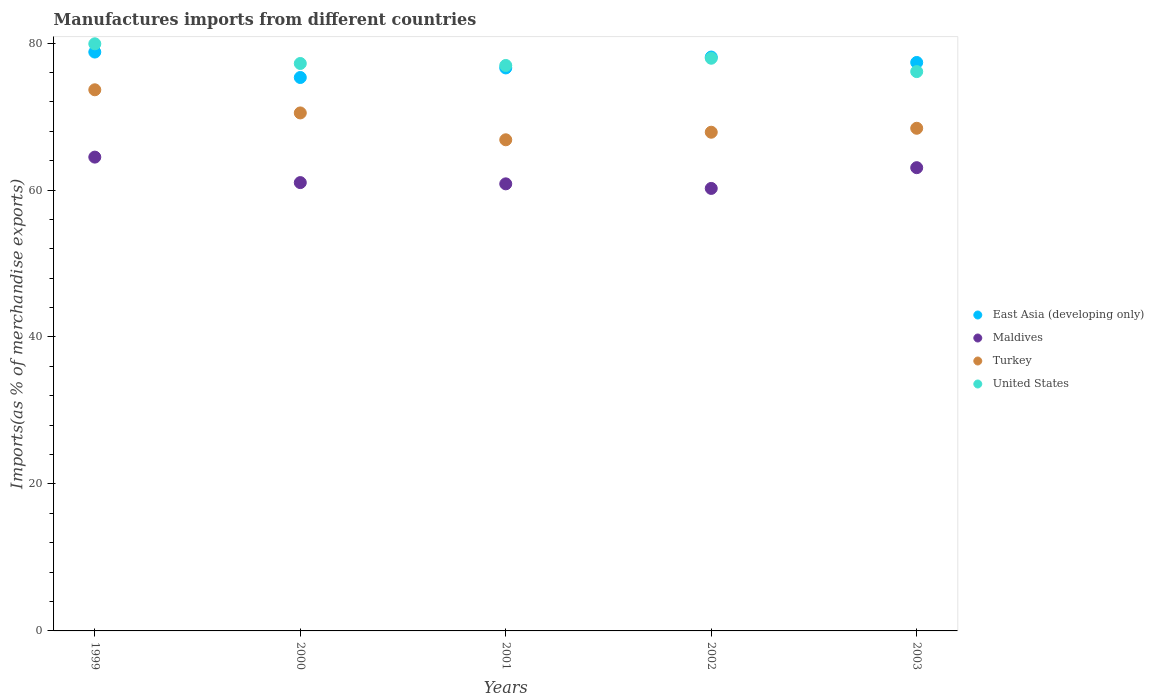How many different coloured dotlines are there?
Your answer should be compact. 4. What is the percentage of imports to different countries in Maldives in 2000?
Your answer should be very brief. 61.01. Across all years, what is the maximum percentage of imports to different countries in East Asia (developing only)?
Provide a succinct answer. 78.77. Across all years, what is the minimum percentage of imports to different countries in Maldives?
Provide a succinct answer. 60.22. In which year was the percentage of imports to different countries in East Asia (developing only) minimum?
Provide a short and direct response. 2000. What is the total percentage of imports to different countries in Turkey in the graph?
Ensure brevity in your answer.  347.23. What is the difference between the percentage of imports to different countries in East Asia (developing only) in 2000 and that in 2001?
Provide a short and direct response. -1.3. What is the difference between the percentage of imports to different countries in Turkey in 2002 and the percentage of imports to different countries in Maldives in 2000?
Ensure brevity in your answer.  6.86. What is the average percentage of imports to different countries in Turkey per year?
Your answer should be compact. 69.45. In the year 2003, what is the difference between the percentage of imports to different countries in United States and percentage of imports to different countries in Turkey?
Your answer should be very brief. 7.71. In how many years, is the percentage of imports to different countries in East Asia (developing only) greater than 56 %?
Provide a succinct answer. 5. What is the ratio of the percentage of imports to different countries in Turkey in 2000 to that in 2002?
Give a very brief answer. 1.04. Is the difference between the percentage of imports to different countries in United States in 1999 and 2003 greater than the difference between the percentage of imports to different countries in Turkey in 1999 and 2003?
Offer a very short reply. No. What is the difference between the highest and the second highest percentage of imports to different countries in Maldives?
Offer a terse response. 1.44. What is the difference between the highest and the lowest percentage of imports to different countries in East Asia (developing only)?
Provide a short and direct response. 3.46. In how many years, is the percentage of imports to different countries in Turkey greater than the average percentage of imports to different countries in Turkey taken over all years?
Provide a succinct answer. 2. Is it the case that in every year, the sum of the percentage of imports to different countries in Maldives and percentage of imports to different countries in Turkey  is greater than the sum of percentage of imports to different countries in East Asia (developing only) and percentage of imports to different countries in United States?
Make the answer very short. No. Is it the case that in every year, the sum of the percentage of imports to different countries in Maldives and percentage of imports to different countries in United States  is greater than the percentage of imports to different countries in Turkey?
Keep it short and to the point. Yes. Does the percentage of imports to different countries in Turkey monotonically increase over the years?
Make the answer very short. No. Is the percentage of imports to different countries in Turkey strictly greater than the percentage of imports to different countries in Maldives over the years?
Your response must be concise. Yes. Is the percentage of imports to different countries in United States strictly less than the percentage of imports to different countries in Turkey over the years?
Make the answer very short. No. What is the difference between two consecutive major ticks on the Y-axis?
Provide a short and direct response. 20. Where does the legend appear in the graph?
Give a very brief answer. Center right. What is the title of the graph?
Your response must be concise. Manufactures imports from different countries. Does "Cyprus" appear as one of the legend labels in the graph?
Provide a short and direct response. No. What is the label or title of the X-axis?
Ensure brevity in your answer.  Years. What is the label or title of the Y-axis?
Keep it short and to the point. Imports(as % of merchandise exports). What is the Imports(as % of merchandise exports) in East Asia (developing only) in 1999?
Give a very brief answer. 78.77. What is the Imports(as % of merchandise exports) in Maldives in 1999?
Your response must be concise. 64.48. What is the Imports(as % of merchandise exports) in Turkey in 1999?
Provide a short and direct response. 73.64. What is the Imports(as % of merchandise exports) in United States in 1999?
Your answer should be compact. 79.9. What is the Imports(as % of merchandise exports) of East Asia (developing only) in 2000?
Give a very brief answer. 75.31. What is the Imports(as % of merchandise exports) of Maldives in 2000?
Make the answer very short. 61.01. What is the Imports(as % of merchandise exports) of Turkey in 2000?
Give a very brief answer. 70.49. What is the Imports(as % of merchandise exports) of United States in 2000?
Your answer should be compact. 77.22. What is the Imports(as % of merchandise exports) in East Asia (developing only) in 2001?
Ensure brevity in your answer.  76.61. What is the Imports(as % of merchandise exports) in Maldives in 2001?
Your response must be concise. 60.84. What is the Imports(as % of merchandise exports) of Turkey in 2001?
Keep it short and to the point. 66.84. What is the Imports(as % of merchandise exports) in United States in 2001?
Give a very brief answer. 76.95. What is the Imports(as % of merchandise exports) of East Asia (developing only) in 2002?
Offer a terse response. 78.09. What is the Imports(as % of merchandise exports) in Maldives in 2002?
Your response must be concise. 60.22. What is the Imports(as % of merchandise exports) in Turkey in 2002?
Ensure brevity in your answer.  67.86. What is the Imports(as % of merchandise exports) of United States in 2002?
Keep it short and to the point. 77.93. What is the Imports(as % of merchandise exports) in East Asia (developing only) in 2003?
Offer a very short reply. 77.36. What is the Imports(as % of merchandise exports) in Maldives in 2003?
Your response must be concise. 63.04. What is the Imports(as % of merchandise exports) of Turkey in 2003?
Provide a short and direct response. 68.4. What is the Imports(as % of merchandise exports) of United States in 2003?
Ensure brevity in your answer.  76.11. Across all years, what is the maximum Imports(as % of merchandise exports) of East Asia (developing only)?
Make the answer very short. 78.77. Across all years, what is the maximum Imports(as % of merchandise exports) of Maldives?
Your response must be concise. 64.48. Across all years, what is the maximum Imports(as % of merchandise exports) in Turkey?
Give a very brief answer. 73.64. Across all years, what is the maximum Imports(as % of merchandise exports) of United States?
Give a very brief answer. 79.9. Across all years, what is the minimum Imports(as % of merchandise exports) in East Asia (developing only)?
Provide a succinct answer. 75.31. Across all years, what is the minimum Imports(as % of merchandise exports) in Maldives?
Give a very brief answer. 60.22. Across all years, what is the minimum Imports(as % of merchandise exports) in Turkey?
Ensure brevity in your answer.  66.84. Across all years, what is the minimum Imports(as % of merchandise exports) of United States?
Offer a terse response. 76.11. What is the total Imports(as % of merchandise exports) in East Asia (developing only) in the graph?
Offer a very short reply. 386.15. What is the total Imports(as % of merchandise exports) in Maldives in the graph?
Provide a succinct answer. 309.58. What is the total Imports(as % of merchandise exports) in Turkey in the graph?
Offer a terse response. 347.23. What is the total Imports(as % of merchandise exports) in United States in the graph?
Provide a short and direct response. 388.11. What is the difference between the Imports(as % of merchandise exports) in East Asia (developing only) in 1999 and that in 2000?
Ensure brevity in your answer.  3.46. What is the difference between the Imports(as % of merchandise exports) of Maldives in 1999 and that in 2000?
Provide a succinct answer. 3.47. What is the difference between the Imports(as % of merchandise exports) in Turkey in 1999 and that in 2000?
Your answer should be compact. 3.15. What is the difference between the Imports(as % of merchandise exports) of United States in 1999 and that in 2000?
Provide a short and direct response. 2.68. What is the difference between the Imports(as % of merchandise exports) in East Asia (developing only) in 1999 and that in 2001?
Offer a terse response. 2.16. What is the difference between the Imports(as % of merchandise exports) of Maldives in 1999 and that in 2001?
Your response must be concise. 3.64. What is the difference between the Imports(as % of merchandise exports) of Turkey in 1999 and that in 2001?
Keep it short and to the point. 6.8. What is the difference between the Imports(as % of merchandise exports) in United States in 1999 and that in 2001?
Your answer should be compact. 2.95. What is the difference between the Imports(as % of merchandise exports) of East Asia (developing only) in 1999 and that in 2002?
Your response must be concise. 0.68. What is the difference between the Imports(as % of merchandise exports) of Maldives in 1999 and that in 2002?
Your answer should be compact. 4.26. What is the difference between the Imports(as % of merchandise exports) in Turkey in 1999 and that in 2002?
Give a very brief answer. 5.77. What is the difference between the Imports(as % of merchandise exports) in United States in 1999 and that in 2002?
Ensure brevity in your answer.  1.96. What is the difference between the Imports(as % of merchandise exports) in East Asia (developing only) in 1999 and that in 2003?
Provide a short and direct response. 1.42. What is the difference between the Imports(as % of merchandise exports) in Maldives in 1999 and that in 2003?
Your answer should be very brief. 1.44. What is the difference between the Imports(as % of merchandise exports) of Turkey in 1999 and that in 2003?
Offer a terse response. 5.24. What is the difference between the Imports(as % of merchandise exports) of United States in 1999 and that in 2003?
Give a very brief answer. 3.78. What is the difference between the Imports(as % of merchandise exports) in East Asia (developing only) in 2000 and that in 2001?
Provide a short and direct response. -1.3. What is the difference between the Imports(as % of merchandise exports) of Maldives in 2000 and that in 2001?
Give a very brief answer. 0.17. What is the difference between the Imports(as % of merchandise exports) in Turkey in 2000 and that in 2001?
Provide a short and direct response. 3.65. What is the difference between the Imports(as % of merchandise exports) of United States in 2000 and that in 2001?
Make the answer very short. 0.27. What is the difference between the Imports(as % of merchandise exports) of East Asia (developing only) in 2000 and that in 2002?
Ensure brevity in your answer.  -2.78. What is the difference between the Imports(as % of merchandise exports) in Maldives in 2000 and that in 2002?
Provide a succinct answer. 0.79. What is the difference between the Imports(as % of merchandise exports) of Turkey in 2000 and that in 2002?
Make the answer very short. 2.63. What is the difference between the Imports(as % of merchandise exports) of United States in 2000 and that in 2002?
Make the answer very short. -0.71. What is the difference between the Imports(as % of merchandise exports) of East Asia (developing only) in 2000 and that in 2003?
Your answer should be very brief. -2.05. What is the difference between the Imports(as % of merchandise exports) of Maldives in 2000 and that in 2003?
Your response must be concise. -2.03. What is the difference between the Imports(as % of merchandise exports) in Turkey in 2000 and that in 2003?
Your answer should be compact. 2.09. What is the difference between the Imports(as % of merchandise exports) of United States in 2000 and that in 2003?
Your answer should be very brief. 1.1. What is the difference between the Imports(as % of merchandise exports) in East Asia (developing only) in 2001 and that in 2002?
Your answer should be very brief. -1.48. What is the difference between the Imports(as % of merchandise exports) of Maldives in 2001 and that in 2002?
Provide a succinct answer. 0.62. What is the difference between the Imports(as % of merchandise exports) of Turkey in 2001 and that in 2002?
Offer a very short reply. -1.03. What is the difference between the Imports(as % of merchandise exports) of United States in 2001 and that in 2002?
Offer a terse response. -0.98. What is the difference between the Imports(as % of merchandise exports) in East Asia (developing only) in 2001 and that in 2003?
Your response must be concise. -0.74. What is the difference between the Imports(as % of merchandise exports) of Maldives in 2001 and that in 2003?
Provide a short and direct response. -2.2. What is the difference between the Imports(as % of merchandise exports) of Turkey in 2001 and that in 2003?
Your answer should be very brief. -1.57. What is the difference between the Imports(as % of merchandise exports) of United States in 2001 and that in 2003?
Ensure brevity in your answer.  0.83. What is the difference between the Imports(as % of merchandise exports) of East Asia (developing only) in 2002 and that in 2003?
Your answer should be very brief. 0.74. What is the difference between the Imports(as % of merchandise exports) of Maldives in 2002 and that in 2003?
Offer a very short reply. -2.82. What is the difference between the Imports(as % of merchandise exports) in Turkey in 2002 and that in 2003?
Keep it short and to the point. -0.54. What is the difference between the Imports(as % of merchandise exports) in United States in 2002 and that in 2003?
Your answer should be compact. 1.82. What is the difference between the Imports(as % of merchandise exports) of East Asia (developing only) in 1999 and the Imports(as % of merchandise exports) of Maldives in 2000?
Keep it short and to the point. 17.76. What is the difference between the Imports(as % of merchandise exports) in East Asia (developing only) in 1999 and the Imports(as % of merchandise exports) in Turkey in 2000?
Make the answer very short. 8.28. What is the difference between the Imports(as % of merchandise exports) in East Asia (developing only) in 1999 and the Imports(as % of merchandise exports) in United States in 2000?
Your answer should be very brief. 1.55. What is the difference between the Imports(as % of merchandise exports) in Maldives in 1999 and the Imports(as % of merchandise exports) in Turkey in 2000?
Your answer should be very brief. -6.01. What is the difference between the Imports(as % of merchandise exports) of Maldives in 1999 and the Imports(as % of merchandise exports) of United States in 2000?
Offer a terse response. -12.74. What is the difference between the Imports(as % of merchandise exports) in Turkey in 1999 and the Imports(as % of merchandise exports) in United States in 2000?
Offer a very short reply. -3.58. What is the difference between the Imports(as % of merchandise exports) of East Asia (developing only) in 1999 and the Imports(as % of merchandise exports) of Maldives in 2001?
Your answer should be compact. 17.93. What is the difference between the Imports(as % of merchandise exports) in East Asia (developing only) in 1999 and the Imports(as % of merchandise exports) in Turkey in 2001?
Ensure brevity in your answer.  11.94. What is the difference between the Imports(as % of merchandise exports) in East Asia (developing only) in 1999 and the Imports(as % of merchandise exports) in United States in 2001?
Give a very brief answer. 1.82. What is the difference between the Imports(as % of merchandise exports) of Maldives in 1999 and the Imports(as % of merchandise exports) of Turkey in 2001?
Offer a terse response. -2.36. What is the difference between the Imports(as % of merchandise exports) of Maldives in 1999 and the Imports(as % of merchandise exports) of United States in 2001?
Provide a short and direct response. -12.47. What is the difference between the Imports(as % of merchandise exports) of Turkey in 1999 and the Imports(as % of merchandise exports) of United States in 2001?
Your response must be concise. -3.31. What is the difference between the Imports(as % of merchandise exports) in East Asia (developing only) in 1999 and the Imports(as % of merchandise exports) in Maldives in 2002?
Make the answer very short. 18.56. What is the difference between the Imports(as % of merchandise exports) in East Asia (developing only) in 1999 and the Imports(as % of merchandise exports) in Turkey in 2002?
Provide a succinct answer. 10.91. What is the difference between the Imports(as % of merchandise exports) of East Asia (developing only) in 1999 and the Imports(as % of merchandise exports) of United States in 2002?
Offer a terse response. 0.84. What is the difference between the Imports(as % of merchandise exports) of Maldives in 1999 and the Imports(as % of merchandise exports) of Turkey in 2002?
Keep it short and to the point. -3.39. What is the difference between the Imports(as % of merchandise exports) in Maldives in 1999 and the Imports(as % of merchandise exports) in United States in 2002?
Make the answer very short. -13.45. What is the difference between the Imports(as % of merchandise exports) in Turkey in 1999 and the Imports(as % of merchandise exports) in United States in 2002?
Your response must be concise. -4.29. What is the difference between the Imports(as % of merchandise exports) of East Asia (developing only) in 1999 and the Imports(as % of merchandise exports) of Maldives in 2003?
Provide a short and direct response. 15.73. What is the difference between the Imports(as % of merchandise exports) in East Asia (developing only) in 1999 and the Imports(as % of merchandise exports) in Turkey in 2003?
Provide a succinct answer. 10.37. What is the difference between the Imports(as % of merchandise exports) in East Asia (developing only) in 1999 and the Imports(as % of merchandise exports) in United States in 2003?
Offer a terse response. 2.66. What is the difference between the Imports(as % of merchandise exports) of Maldives in 1999 and the Imports(as % of merchandise exports) of Turkey in 2003?
Offer a very short reply. -3.93. What is the difference between the Imports(as % of merchandise exports) in Maldives in 1999 and the Imports(as % of merchandise exports) in United States in 2003?
Your answer should be very brief. -11.64. What is the difference between the Imports(as % of merchandise exports) in Turkey in 1999 and the Imports(as % of merchandise exports) in United States in 2003?
Give a very brief answer. -2.48. What is the difference between the Imports(as % of merchandise exports) of East Asia (developing only) in 2000 and the Imports(as % of merchandise exports) of Maldives in 2001?
Provide a succinct answer. 14.47. What is the difference between the Imports(as % of merchandise exports) in East Asia (developing only) in 2000 and the Imports(as % of merchandise exports) in Turkey in 2001?
Provide a succinct answer. 8.48. What is the difference between the Imports(as % of merchandise exports) of East Asia (developing only) in 2000 and the Imports(as % of merchandise exports) of United States in 2001?
Ensure brevity in your answer.  -1.64. What is the difference between the Imports(as % of merchandise exports) of Maldives in 2000 and the Imports(as % of merchandise exports) of Turkey in 2001?
Make the answer very short. -5.83. What is the difference between the Imports(as % of merchandise exports) of Maldives in 2000 and the Imports(as % of merchandise exports) of United States in 2001?
Your response must be concise. -15.94. What is the difference between the Imports(as % of merchandise exports) of Turkey in 2000 and the Imports(as % of merchandise exports) of United States in 2001?
Keep it short and to the point. -6.46. What is the difference between the Imports(as % of merchandise exports) in East Asia (developing only) in 2000 and the Imports(as % of merchandise exports) in Maldives in 2002?
Ensure brevity in your answer.  15.1. What is the difference between the Imports(as % of merchandise exports) in East Asia (developing only) in 2000 and the Imports(as % of merchandise exports) in Turkey in 2002?
Offer a terse response. 7.45. What is the difference between the Imports(as % of merchandise exports) in East Asia (developing only) in 2000 and the Imports(as % of merchandise exports) in United States in 2002?
Your response must be concise. -2.62. What is the difference between the Imports(as % of merchandise exports) of Maldives in 2000 and the Imports(as % of merchandise exports) of Turkey in 2002?
Give a very brief answer. -6.86. What is the difference between the Imports(as % of merchandise exports) in Maldives in 2000 and the Imports(as % of merchandise exports) in United States in 2002?
Provide a succinct answer. -16.92. What is the difference between the Imports(as % of merchandise exports) of Turkey in 2000 and the Imports(as % of merchandise exports) of United States in 2002?
Give a very brief answer. -7.44. What is the difference between the Imports(as % of merchandise exports) in East Asia (developing only) in 2000 and the Imports(as % of merchandise exports) in Maldives in 2003?
Your response must be concise. 12.27. What is the difference between the Imports(as % of merchandise exports) of East Asia (developing only) in 2000 and the Imports(as % of merchandise exports) of Turkey in 2003?
Offer a terse response. 6.91. What is the difference between the Imports(as % of merchandise exports) in East Asia (developing only) in 2000 and the Imports(as % of merchandise exports) in United States in 2003?
Your response must be concise. -0.8. What is the difference between the Imports(as % of merchandise exports) in Maldives in 2000 and the Imports(as % of merchandise exports) in Turkey in 2003?
Your answer should be very brief. -7.39. What is the difference between the Imports(as % of merchandise exports) in Maldives in 2000 and the Imports(as % of merchandise exports) in United States in 2003?
Your answer should be compact. -15.1. What is the difference between the Imports(as % of merchandise exports) of Turkey in 2000 and the Imports(as % of merchandise exports) of United States in 2003?
Your answer should be compact. -5.62. What is the difference between the Imports(as % of merchandise exports) in East Asia (developing only) in 2001 and the Imports(as % of merchandise exports) in Maldives in 2002?
Provide a succinct answer. 16.4. What is the difference between the Imports(as % of merchandise exports) in East Asia (developing only) in 2001 and the Imports(as % of merchandise exports) in Turkey in 2002?
Offer a very short reply. 8.75. What is the difference between the Imports(as % of merchandise exports) of East Asia (developing only) in 2001 and the Imports(as % of merchandise exports) of United States in 2002?
Ensure brevity in your answer.  -1.32. What is the difference between the Imports(as % of merchandise exports) of Maldives in 2001 and the Imports(as % of merchandise exports) of Turkey in 2002?
Your answer should be very brief. -7.03. What is the difference between the Imports(as % of merchandise exports) in Maldives in 2001 and the Imports(as % of merchandise exports) in United States in 2002?
Your answer should be very brief. -17.09. What is the difference between the Imports(as % of merchandise exports) of Turkey in 2001 and the Imports(as % of merchandise exports) of United States in 2002?
Your answer should be compact. -11.1. What is the difference between the Imports(as % of merchandise exports) in East Asia (developing only) in 2001 and the Imports(as % of merchandise exports) in Maldives in 2003?
Your answer should be very brief. 13.57. What is the difference between the Imports(as % of merchandise exports) of East Asia (developing only) in 2001 and the Imports(as % of merchandise exports) of Turkey in 2003?
Your response must be concise. 8.21. What is the difference between the Imports(as % of merchandise exports) of East Asia (developing only) in 2001 and the Imports(as % of merchandise exports) of United States in 2003?
Provide a succinct answer. 0.5. What is the difference between the Imports(as % of merchandise exports) in Maldives in 2001 and the Imports(as % of merchandise exports) in Turkey in 2003?
Your answer should be compact. -7.56. What is the difference between the Imports(as % of merchandise exports) in Maldives in 2001 and the Imports(as % of merchandise exports) in United States in 2003?
Your answer should be compact. -15.27. What is the difference between the Imports(as % of merchandise exports) in Turkey in 2001 and the Imports(as % of merchandise exports) in United States in 2003?
Provide a short and direct response. -9.28. What is the difference between the Imports(as % of merchandise exports) in East Asia (developing only) in 2002 and the Imports(as % of merchandise exports) in Maldives in 2003?
Offer a very short reply. 15.05. What is the difference between the Imports(as % of merchandise exports) in East Asia (developing only) in 2002 and the Imports(as % of merchandise exports) in Turkey in 2003?
Offer a terse response. 9.69. What is the difference between the Imports(as % of merchandise exports) of East Asia (developing only) in 2002 and the Imports(as % of merchandise exports) of United States in 2003?
Ensure brevity in your answer.  1.98. What is the difference between the Imports(as % of merchandise exports) in Maldives in 2002 and the Imports(as % of merchandise exports) in Turkey in 2003?
Provide a succinct answer. -8.19. What is the difference between the Imports(as % of merchandise exports) in Maldives in 2002 and the Imports(as % of merchandise exports) in United States in 2003?
Offer a terse response. -15.9. What is the difference between the Imports(as % of merchandise exports) in Turkey in 2002 and the Imports(as % of merchandise exports) in United States in 2003?
Keep it short and to the point. -8.25. What is the average Imports(as % of merchandise exports) in East Asia (developing only) per year?
Keep it short and to the point. 77.23. What is the average Imports(as % of merchandise exports) in Maldives per year?
Give a very brief answer. 61.92. What is the average Imports(as % of merchandise exports) in Turkey per year?
Ensure brevity in your answer.  69.45. What is the average Imports(as % of merchandise exports) in United States per year?
Keep it short and to the point. 77.62. In the year 1999, what is the difference between the Imports(as % of merchandise exports) of East Asia (developing only) and Imports(as % of merchandise exports) of Maldives?
Give a very brief answer. 14.3. In the year 1999, what is the difference between the Imports(as % of merchandise exports) in East Asia (developing only) and Imports(as % of merchandise exports) in Turkey?
Your response must be concise. 5.13. In the year 1999, what is the difference between the Imports(as % of merchandise exports) of East Asia (developing only) and Imports(as % of merchandise exports) of United States?
Your answer should be compact. -1.12. In the year 1999, what is the difference between the Imports(as % of merchandise exports) in Maldives and Imports(as % of merchandise exports) in Turkey?
Give a very brief answer. -9.16. In the year 1999, what is the difference between the Imports(as % of merchandise exports) of Maldives and Imports(as % of merchandise exports) of United States?
Give a very brief answer. -15.42. In the year 1999, what is the difference between the Imports(as % of merchandise exports) in Turkey and Imports(as % of merchandise exports) in United States?
Your response must be concise. -6.26. In the year 2000, what is the difference between the Imports(as % of merchandise exports) of East Asia (developing only) and Imports(as % of merchandise exports) of Maldives?
Your answer should be compact. 14.3. In the year 2000, what is the difference between the Imports(as % of merchandise exports) of East Asia (developing only) and Imports(as % of merchandise exports) of Turkey?
Your answer should be compact. 4.82. In the year 2000, what is the difference between the Imports(as % of merchandise exports) in East Asia (developing only) and Imports(as % of merchandise exports) in United States?
Your answer should be compact. -1.91. In the year 2000, what is the difference between the Imports(as % of merchandise exports) in Maldives and Imports(as % of merchandise exports) in Turkey?
Your answer should be very brief. -9.48. In the year 2000, what is the difference between the Imports(as % of merchandise exports) in Maldives and Imports(as % of merchandise exports) in United States?
Your answer should be compact. -16.21. In the year 2000, what is the difference between the Imports(as % of merchandise exports) of Turkey and Imports(as % of merchandise exports) of United States?
Your answer should be very brief. -6.73. In the year 2001, what is the difference between the Imports(as % of merchandise exports) in East Asia (developing only) and Imports(as % of merchandise exports) in Maldives?
Offer a very short reply. 15.77. In the year 2001, what is the difference between the Imports(as % of merchandise exports) in East Asia (developing only) and Imports(as % of merchandise exports) in Turkey?
Give a very brief answer. 9.78. In the year 2001, what is the difference between the Imports(as % of merchandise exports) in East Asia (developing only) and Imports(as % of merchandise exports) in United States?
Ensure brevity in your answer.  -0.34. In the year 2001, what is the difference between the Imports(as % of merchandise exports) of Maldives and Imports(as % of merchandise exports) of Turkey?
Make the answer very short. -6. In the year 2001, what is the difference between the Imports(as % of merchandise exports) of Maldives and Imports(as % of merchandise exports) of United States?
Your answer should be very brief. -16.11. In the year 2001, what is the difference between the Imports(as % of merchandise exports) in Turkey and Imports(as % of merchandise exports) in United States?
Ensure brevity in your answer.  -10.11. In the year 2002, what is the difference between the Imports(as % of merchandise exports) of East Asia (developing only) and Imports(as % of merchandise exports) of Maldives?
Offer a very short reply. 17.88. In the year 2002, what is the difference between the Imports(as % of merchandise exports) of East Asia (developing only) and Imports(as % of merchandise exports) of Turkey?
Offer a terse response. 10.23. In the year 2002, what is the difference between the Imports(as % of merchandise exports) of East Asia (developing only) and Imports(as % of merchandise exports) of United States?
Provide a short and direct response. 0.16. In the year 2002, what is the difference between the Imports(as % of merchandise exports) of Maldives and Imports(as % of merchandise exports) of Turkey?
Your answer should be very brief. -7.65. In the year 2002, what is the difference between the Imports(as % of merchandise exports) of Maldives and Imports(as % of merchandise exports) of United States?
Your answer should be very brief. -17.71. In the year 2002, what is the difference between the Imports(as % of merchandise exports) in Turkey and Imports(as % of merchandise exports) in United States?
Your answer should be very brief. -10.07. In the year 2003, what is the difference between the Imports(as % of merchandise exports) in East Asia (developing only) and Imports(as % of merchandise exports) in Maldives?
Keep it short and to the point. 14.32. In the year 2003, what is the difference between the Imports(as % of merchandise exports) of East Asia (developing only) and Imports(as % of merchandise exports) of Turkey?
Your answer should be compact. 8.96. In the year 2003, what is the difference between the Imports(as % of merchandise exports) of East Asia (developing only) and Imports(as % of merchandise exports) of United States?
Ensure brevity in your answer.  1.24. In the year 2003, what is the difference between the Imports(as % of merchandise exports) in Maldives and Imports(as % of merchandise exports) in Turkey?
Ensure brevity in your answer.  -5.36. In the year 2003, what is the difference between the Imports(as % of merchandise exports) in Maldives and Imports(as % of merchandise exports) in United States?
Provide a short and direct response. -13.07. In the year 2003, what is the difference between the Imports(as % of merchandise exports) of Turkey and Imports(as % of merchandise exports) of United States?
Your answer should be compact. -7.71. What is the ratio of the Imports(as % of merchandise exports) in East Asia (developing only) in 1999 to that in 2000?
Give a very brief answer. 1.05. What is the ratio of the Imports(as % of merchandise exports) in Maldives in 1999 to that in 2000?
Offer a very short reply. 1.06. What is the ratio of the Imports(as % of merchandise exports) in Turkey in 1999 to that in 2000?
Ensure brevity in your answer.  1.04. What is the ratio of the Imports(as % of merchandise exports) of United States in 1999 to that in 2000?
Offer a terse response. 1.03. What is the ratio of the Imports(as % of merchandise exports) in East Asia (developing only) in 1999 to that in 2001?
Your response must be concise. 1.03. What is the ratio of the Imports(as % of merchandise exports) of Maldives in 1999 to that in 2001?
Provide a succinct answer. 1.06. What is the ratio of the Imports(as % of merchandise exports) of Turkey in 1999 to that in 2001?
Provide a succinct answer. 1.1. What is the ratio of the Imports(as % of merchandise exports) in United States in 1999 to that in 2001?
Keep it short and to the point. 1.04. What is the ratio of the Imports(as % of merchandise exports) in East Asia (developing only) in 1999 to that in 2002?
Give a very brief answer. 1.01. What is the ratio of the Imports(as % of merchandise exports) in Maldives in 1999 to that in 2002?
Make the answer very short. 1.07. What is the ratio of the Imports(as % of merchandise exports) of Turkey in 1999 to that in 2002?
Provide a short and direct response. 1.09. What is the ratio of the Imports(as % of merchandise exports) in United States in 1999 to that in 2002?
Your answer should be compact. 1.03. What is the ratio of the Imports(as % of merchandise exports) in East Asia (developing only) in 1999 to that in 2003?
Offer a terse response. 1.02. What is the ratio of the Imports(as % of merchandise exports) in Maldives in 1999 to that in 2003?
Provide a succinct answer. 1.02. What is the ratio of the Imports(as % of merchandise exports) of Turkey in 1999 to that in 2003?
Keep it short and to the point. 1.08. What is the ratio of the Imports(as % of merchandise exports) in United States in 1999 to that in 2003?
Your response must be concise. 1.05. What is the ratio of the Imports(as % of merchandise exports) of East Asia (developing only) in 2000 to that in 2001?
Make the answer very short. 0.98. What is the ratio of the Imports(as % of merchandise exports) of Turkey in 2000 to that in 2001?
Provide a succinct answer. 1.05. What is the ratio of the Imports(as % of merchandise exports) in United States in 2000 to that in 2001?
Offer a terse response. 1. What is the ratio of the Imports(as % of merchandise exports) in East Asia (developing only) in 2000 to that in 2002?
Ensure brevity in your answer.  0.96. What is the ratio of the Imports(as % of merchandise exports) of Maldives in 2000 to that in 2002?
Offer a very short reply. 1.01. What is the ratio of the Imports(as % of merchandise exports) in Turkey in 2000 to that in 2002?
Offer a very short reply. 1.04. What is the ratio of the Imports(as % of merchandise exports) in East Asia (developing only) in 2000 to that in 2003?
Keep it short and to the point. 0.97. What is the ratio of the Imports(as % of merchandise exports) of Maldives in 2000 to that in 2003?
Provide a short and direct response. 0.97. What is the ratio of the Imports(as % of merchandise exports) of Turkey in 2000 to that in 2003?
Your answer should be compact. 1.03. What is the ratio of the Imports(as % of merchandise exports) in United States in 2000 to that in 2003?
Offer a terse response. 1.01. What is the ratio of the Imports(as % of merchandise exports) in Maldives in 2001 to that in 2002?
Offer a very short reply. 1.01. What is the ratio of the Imports(as % of merchandise exports) of United States in 2001 to that in 2002?
Make the answer very short. 0.99. What is the ratio of the Imports(as % of merchandise exports) in East Asia (developing only) in 2001 to that in 2003?
Provide a short and direct response. 0.99. What is the ratio of the Imports(as % of merchandise exports) in Maldives in 2001 to that in 2003?
Make the answer very short. 0.97. What is the ratio of the Imports(as % of merchandise exports) in Turkey in 2001 to that in 2003?
Give a very brief answer. 0.98. What is the ratio of the Imports(as % of merchandise exports) of East Asia (developing only) in 2002 to that in 2003?
Provide a short and direct response. 1.01. What is the ratio of the Imports(as % of merchandise exports) in Maldives in 2002 to that in 2003?
Offer a terse response. 0.96. What is the ratio of the Imports(as % of merchandise exports) of United States in 2002 to that in 2003?
Your answer should be very brief. 1.02. What is the difference between the highest and the second highest Imports(as % of merchandise exports) of East Asia (developing only)?
Offer a very short reply. 0.68. What is the difference between the highest and the second highest Imports(as % of merchandise exports) of Maldives?
Offer a very short reply. 1.44. What is the difference between the highest and the second highest Imports(as % of merchandise exports) in Turkey?
Make the answer very short. 3.15. What is the difference between the highest and the second highest Imports(as % of merchandise exports) of United States?
Your answer should be very brief. 1.96. What is the difference between the highest and the lowest Imports(as % of merchandise exports) in East Asia (developing only)?
Give a very brief answer. 3.46. What is the difference between the highest and the lowest Imports(as % of merchandise exports) of Maldives?
Your answer should be compact. 4.26. What is the difference between the highest and the lowest Imports(as % of merchandise exports) in Turkey?
Ensure brevity in your answer.  6.8. What is the difference between the highest and the lowest Imports(as % of merchandise exports) in United States?
Provide a succinct answer. 3.78. 